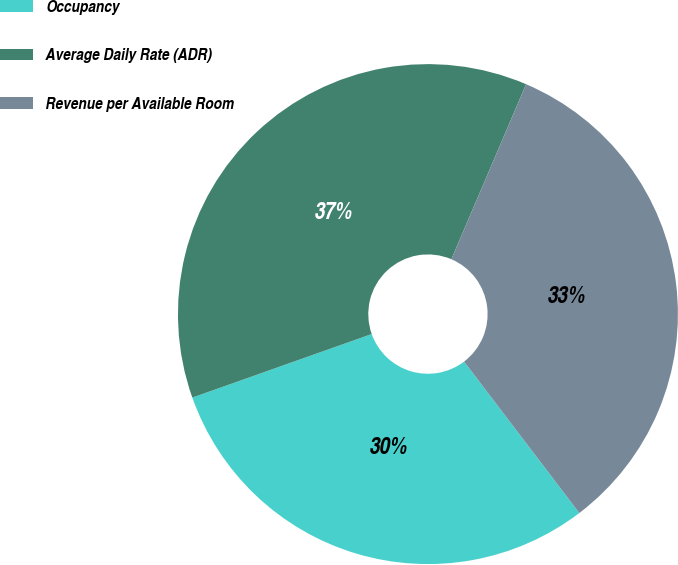<chart> <loc_0><loc_0><loc_500><loc_500><pie_chart><fcel>Occupancy<fcel>Average Daily Rate (ADR)<fcel>Revenue per Available Room<nl><fcel>29.93%<fcel>36.84%<fcel>33.22%<nl></chart> 